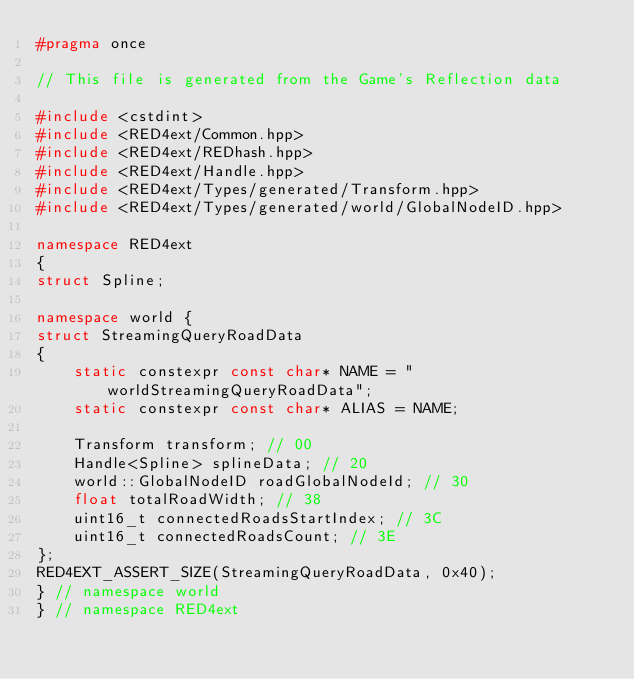<code> <loc_0><loc_0><loc_500><loc_500><_C++_>#pragma once

// This file is generated from the Game's Reflection data

#include <cstdint>
#include <RED4ext/Common.hpp>
#include <RED4ext/REDhash.hpp>
#include <RED4ext/Handle.hpp>
#include <RED4ext/Types/generated/Transform.hpp>
#include <RED4ext/Types/generated/world/GlobalNodeID.hpp>

namespace RED4ext
{
struct Spline;

namespace world { 
struct StreamingQueryRoadData
{
    static constexpr const char* NAME = "worldStreamingQueryRoadData";
    static constexpr const char* ALIAS = NAME;

    Transform transform; // 00
    Handle<Spline> splineData; // 20
    world::GlobalNodeID roadGlobalNodeId; // 30
    float totalRoadWidth; // 38
    uint16_t connectedRoadsStartIndex; // 3C
    uint16_t connectedRoadsCount; // 3E
};
RED4EXT_ASSERT_SIZE(StreamingQueryRoadData, 0x40);
} // namespace world
} // namespace RED4ext
</code> 